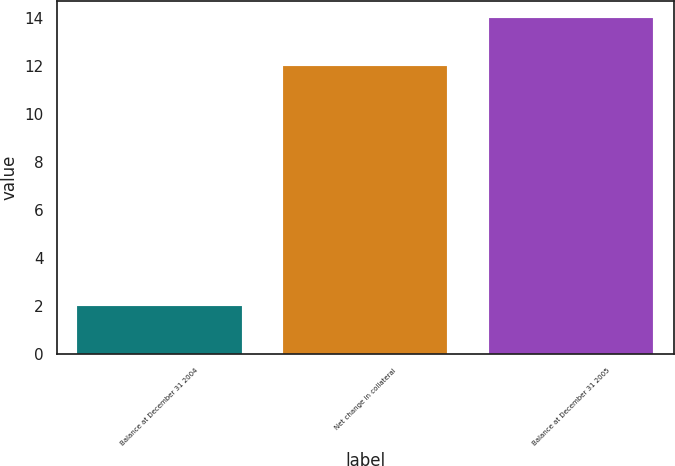Convert chart. <chart><loc_0><loc_0><loc_500><loc_500><bar_chart><fcel>Balance at December 31 2004<fcel>Net change in collateral<fcel>Balance at December 31 2005<nl><fcel>2<fcel>12<fcel>14<nl></chart> 